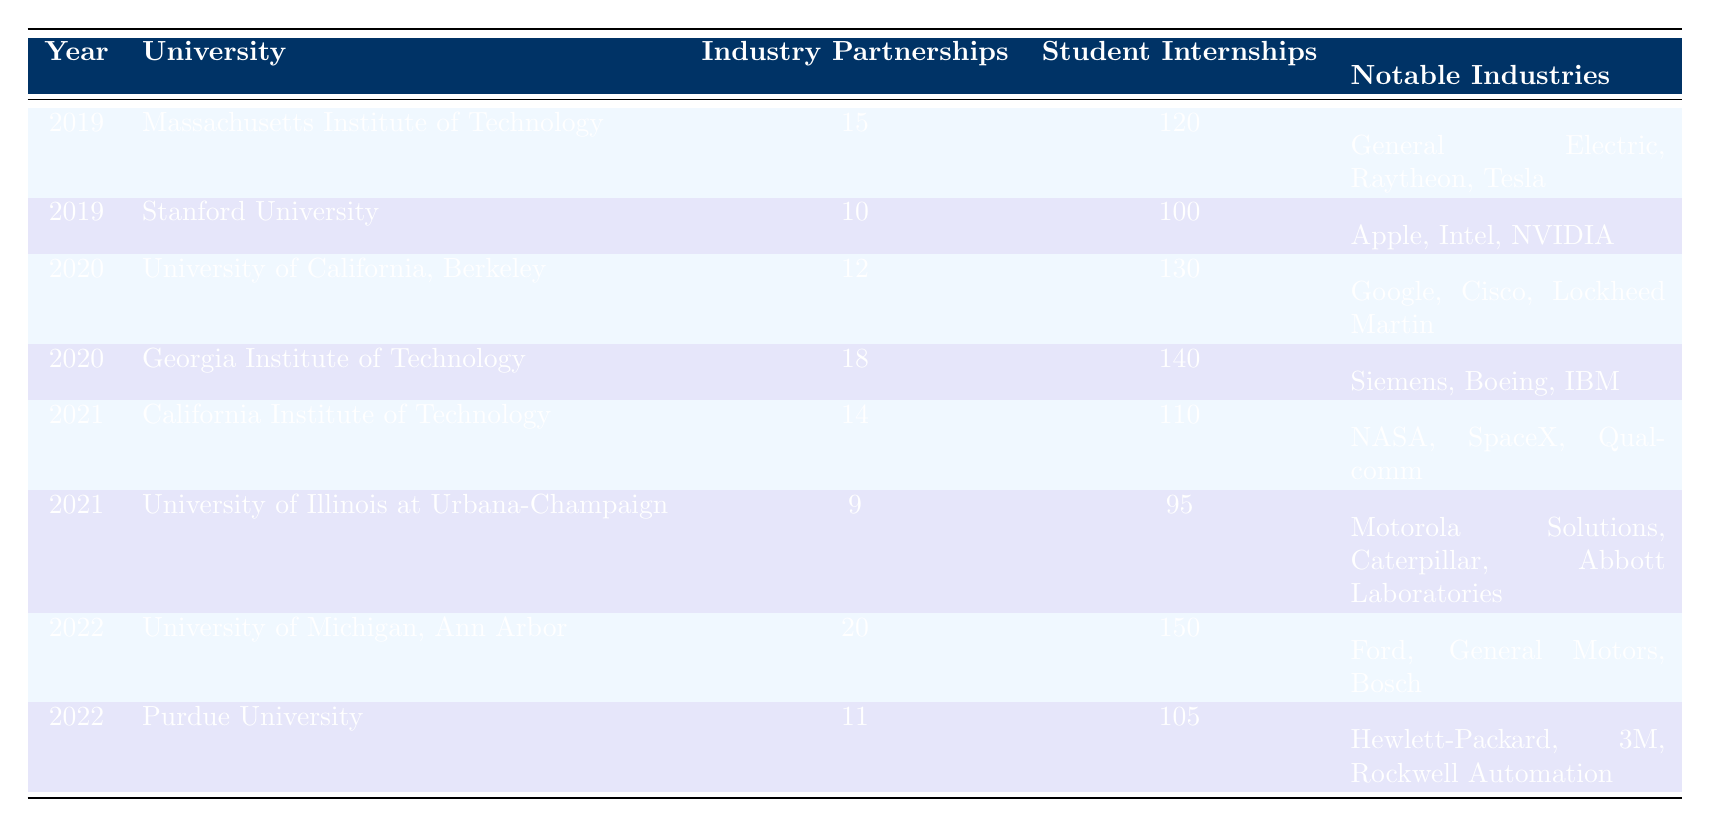What university had the highest number of industry partnerships in 2022? In 2022, the University of Michigan, Ann Arbor had 20 industry partnerships, which is higher than Purdue University, which had 11. Therefore, the University of Michigan had the highest number of industry partnerships in that year.
Answer: University of Michigan, Ann Arbor How many total student internships were reported by all universities in 2019? The total number of student internships in 2019 is calculated by adding the internships from each university: 120 (MIT) + 100 (Stanford) = 220.
Answer: 220 Is it true that Georgia Institute of Technology had more industry partnerships in 2020 than the University of California, Berkeley? Yes, the Georgia Institute of Technology had 18 industry partnerships in 2020, while the University of California, Berkeley had 12. Therefore, it's true.
Answer: Yes What is the average number of student internships across all universities in 2021? To find the average, add the student internships from both universities in 2021 (110 for Caltech and 95 for UIUC), which totals 205. Then divide by the number of universities (2) to get 205/2 = 102.5.
Answer: 102.5 Which university had notable partnerships with Tesla? The Massachusetts Institute of Technology had notable partnerships with Tesla in 2019 according to the data provided.
Answer: Massachusetts Institute of Technology How many more industry partnerships did the University of Michigan, Ann Arbor have compared to Purdue University in 2022? The University of Michigan had 20 partnerships and Purdue University had 11. The difference is calculated as 20 - 11 = 9.
Answer: 9 What year saw the highest number of student internships from the data? The year 2022 saw the highest number of student internships with a total of 150 from the University of Michigan, Ann Arbor, compared to all other years.
Answer: 2022 Calculate the median number of industry partnerships reported across all years. The data points for industry partnerships are 15, 10, 12, 18, 14, 9, 20, and 11. Arranging these values in order gives us 9, 10, 11, 12, 14, 15, 18, 20. Since there are 8 data points, the median is the average of the 4th and 5th values: (12 + 14) / 2 = 13.
Answer: 13 Did the number of student internships increase every year from 2019 to 2022? No, from 2019 to 2020, the internships increased, but from 2021 to 2022, while they increased again, the internships for 2021 compared to 2022 show variability, therefore it cannot be said that they increased every year.
Answer: No Which notable industry partnerships were common between the universities in 2020? The data does not report any notable industries being common between the universities in 2020; UC Berkeley had partnerships with Google, Cisco, and Lockheed Martin whereas Georgia Tech had Siemens, Boeing, and IBM, indicating no overlap.
Answer: None 